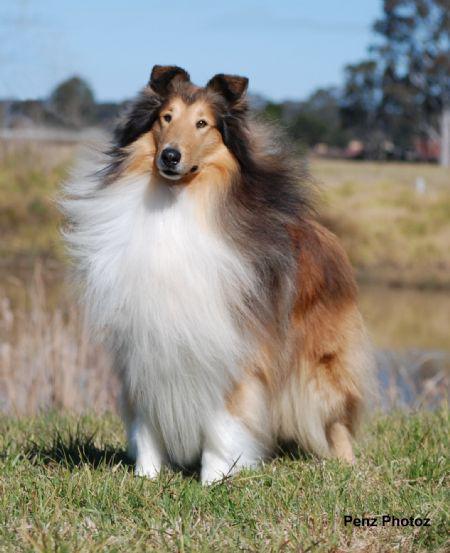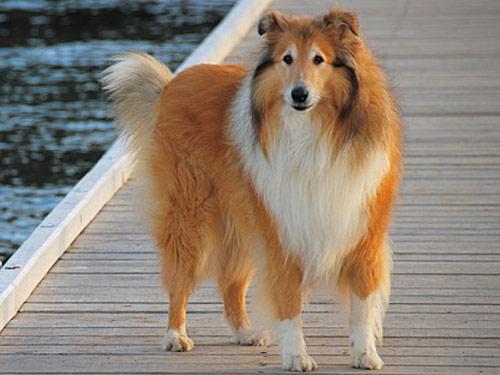The first image is the image on the left, the second image is the image on the right. Examine the images to the left and right. Is the description "The right image shows a collie posed on green grass." accurate? Answer yes or no. No. 